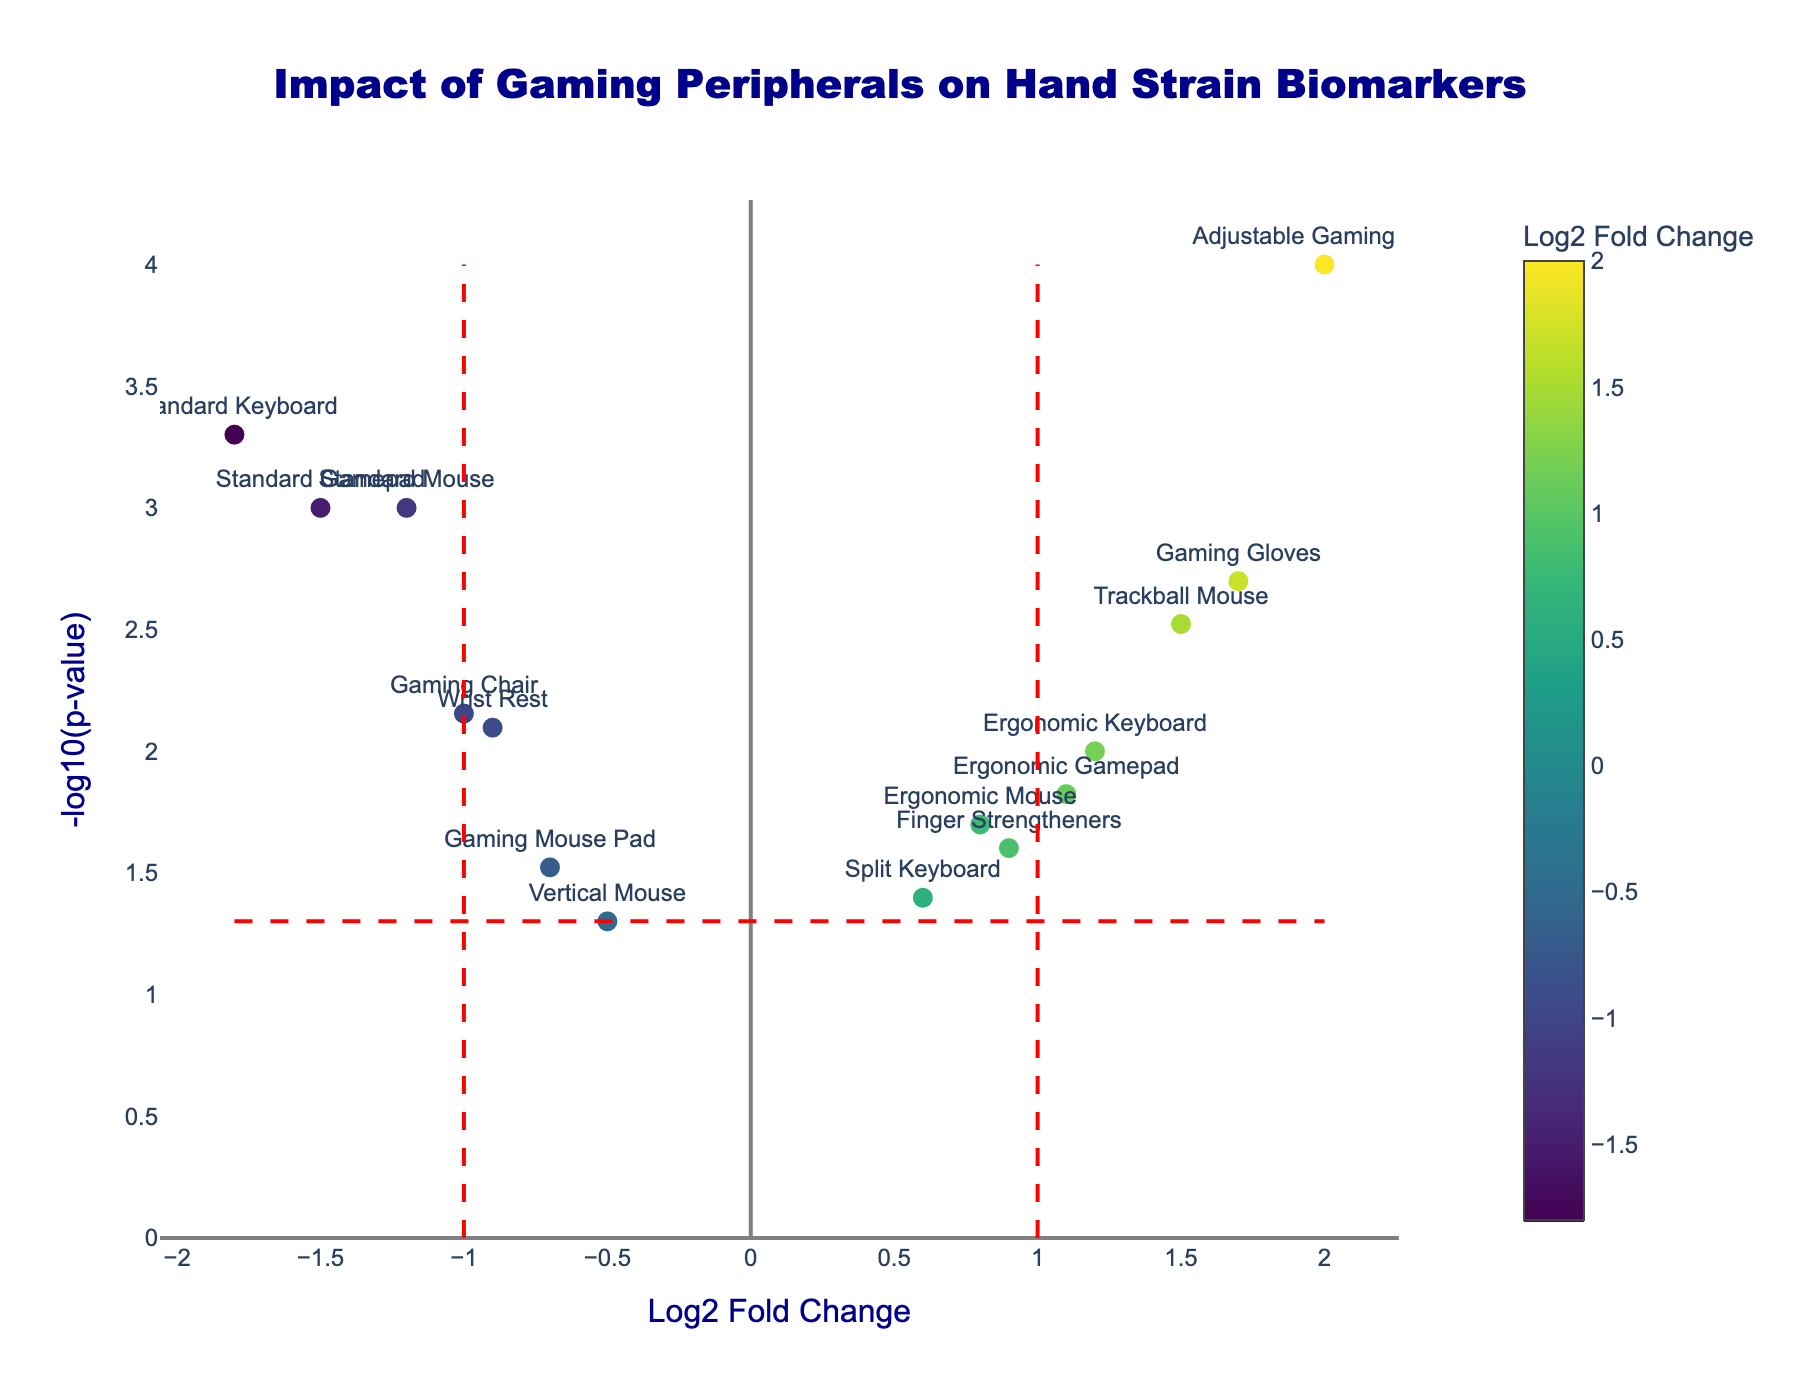Which peripheral has the highest log2 fold change? To find the peripheral with the highest log2 fold change, we look for the data point farthest to the right on the x-axis. "Adjustable Gaming Desk" is the rightmost point with a log2 fold change of 2.0.
Answer: Adjustable Gaming Desk What is the p-value threshold indicated by the horizontal red dashed line? The horizontal red dashed line represents the threshold for statistical significance at p = 0.05. The y-axis value at this line is -log10(0.05). Calculating -log10(0.05) gives approximately 1.3.
Answer: 0.05 Which peripherals have a log2 fold change less than -1 and a statistically significant p-value? To determine this, we identify peripherals to the left of the vertical line at -1 and above the horizontal line representing -log10(0.05). These are "Standard Mouse," "Standard Keyboard," and "Standard Gamepad."
Answer: Standard Mouse, Standard Keyboard, Standard Gamepad How many data points are above the horizontal line indicating p < 0.05? To find this, we count the number of data points above the red dashed horizontal line (y = ~1.3). There are 9 such points.
Answer: 9 Which peripheral has the lowest p-value? The lowest p-value corresponds to the highest -log10(p-value). The tallest point on the y-axis is "Adjustable Gaming Desk" with -log10(pValue) = 4.
Answer: Adjustable Gaming Desk What is the log2 fold change of the "Gaming Gloves"? Hovering over or finding the data point labeled "Gaming Gloves" shows its log2 fold change on the x-axis. The log2 fold change for "Gaming Gloves" is 1.7.
Answer: 1.7 Compare the log2 fold change between "Ergonomic Mouse" and "Vertical Mouse." Which one is higher? To compare, we look at their positions on the x-axis. "Ergonomic Mouse" has a log2 fold change of 0.8, while "Vertical Mouse" has a log2 fold change of -0.5.
Answer: Ergonomic Mouse What are the log2 fold change and p-value for "Gaming Chair"? Hovering over the "Gaming Chair" data point or referring to the data shows its values. "Gaming Chair" has a log2 fold change of -1.0 and a p-value of 0.007.
Answer: -1.0, 0.007 Which peripherals show a positive log2 fold change and are statistically significant? To identify these, we look for points to the right of the vertical line at 1 and above the horizontal line representing -log10(0.05). These would include "Trackball Mouse," "Ergonomic Keyboard," "Gaming Gloves," and "Adjustable Gaming Desk."
Answer: Trackball Mouse, Ergonomic Keyboard, Gaming Gloves, Adjustable Gaming Desk What does a negative log2 fold change suggest about a peripheral's impact on hand strain biomarkers? A negative log2 fold change value suggests that the peripheral is associated with a reduction in hand strain biomarkers. This means it could potentially be beneficial in reducing hand strain.
Answer: Reduction in hand strain biomarkers 